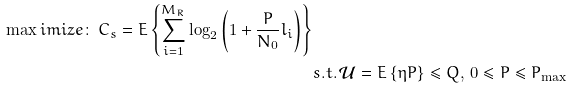<formula> <loc_0><loc_0><loc_500><loc_500>{ } \max i m i z e \colon \, C _ { s } = E \left \{ \sum _ { i = 1 } ^ { M _ { R } } \log _ { 2 } \left ( 1 + \frac { P } { N _ { 0 } } l _ { i } \right ) \right \} \\ & s . t . \, { \mathcal { U } } = E \left \{ \eta P \right \} \leq Q , \, 0 \leq P \leq P _ { \max }</formula> 